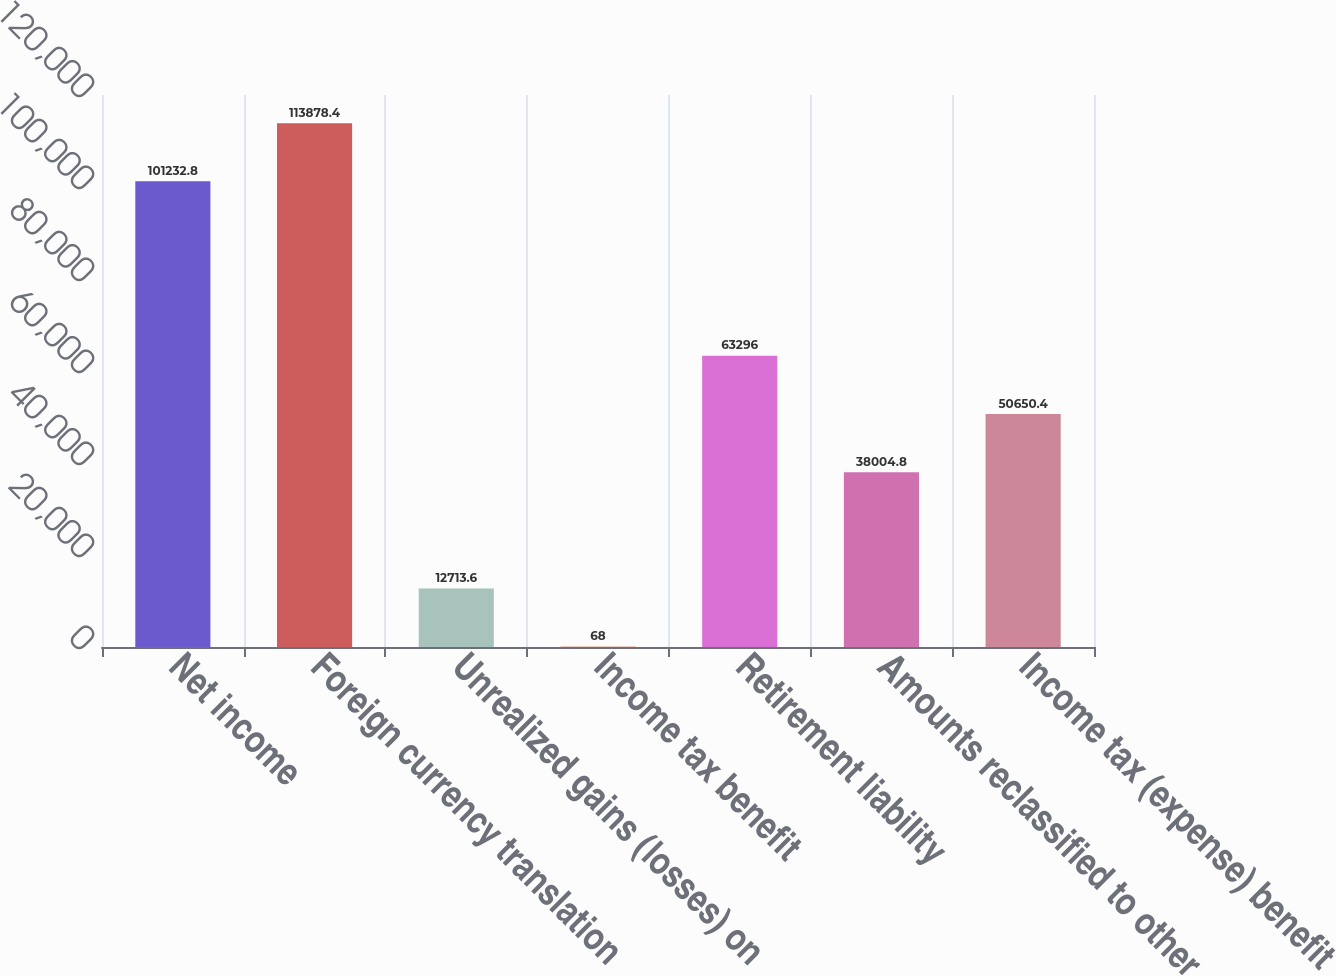Convert chart to OTSL. <chart><loc_0><loc_0><loc_500><loc_500><bar_chart><fcel>Net income<fcel>Foreign currency translation<fcel>Unrealized gains (losses) on<fcel>Income tax benefit<fcel>Retirement liability<fcel>Amounts reclassified to other<fcel>Income tax (expense) benefit<nl><fcel>101233<fcel>113878<fcel>12713.6<fcel>68<fcel>63296<fcel>38004.8<fcel>50650.4<nl></chart> 